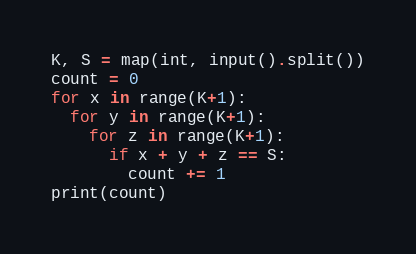<code> <loc_0><loc_0><loc_500><loc_500><_Python_>K, S = map(int, input().split())
count = 0
for x in range(K+1):
  for y in range(K+1):
    for z in range(K+1):
      if x + y + z == S:
        count += 1
print(count)</code> 